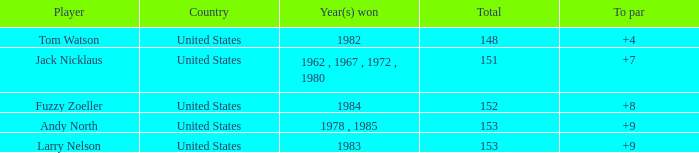From which country does the player with a total less than 153 who won in 1984 originate? United States. 